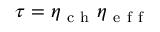<formula> <loc_0><loc_0><loc_500><loc_500>\tau = \eta _ { c h } \eta _ { e f f }</formula> 